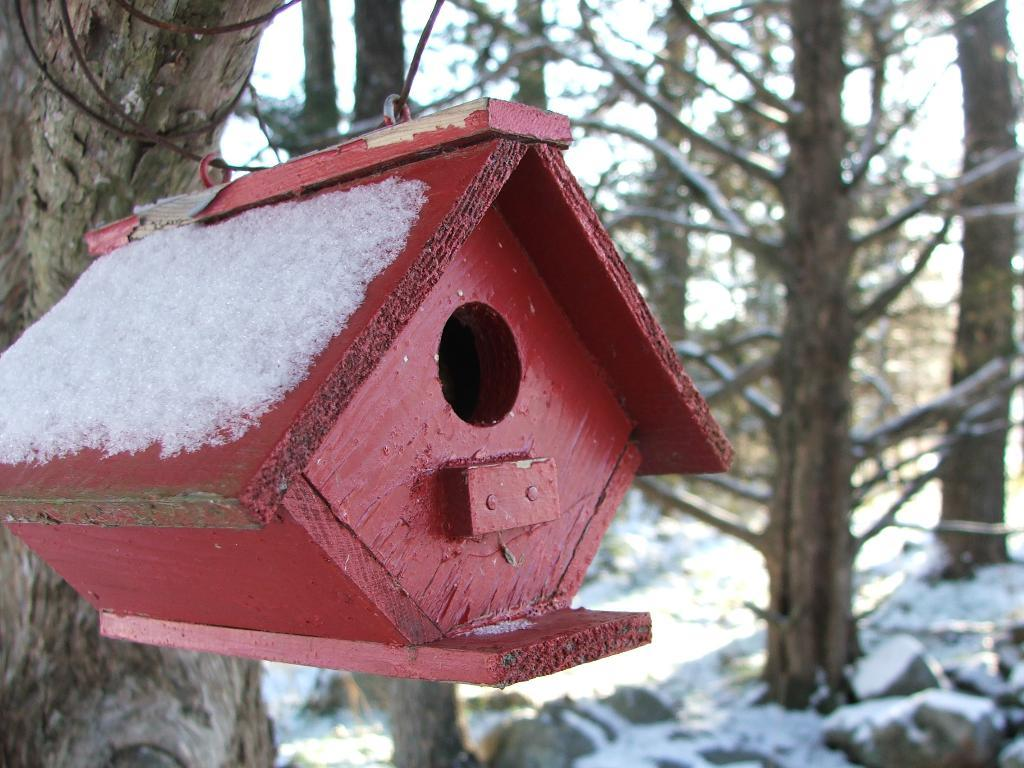What type of house is in the image? There is a wooden house in the image. What can be seen in the background of the image? There are trees in the background of the image. What is at the bottom of the image? There are rocks at the bottom of the image. What is covering the surface in the image? There is snow on the surface in the image. Can you see the root of the tree in the image? There is no root of the tree visible in the image; only the trees themselves are visible in the background. 